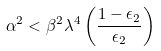<formula> <loc_0><loc_0><loc_500><loc_500>\alpha ^ { 2 } < \beta ^ { 2 } \lambda ^ { 4 } \left ( \frac { 1 - \epsilon _ { 2 } } { \epsilon _ { 2 } } \right )</formula> 